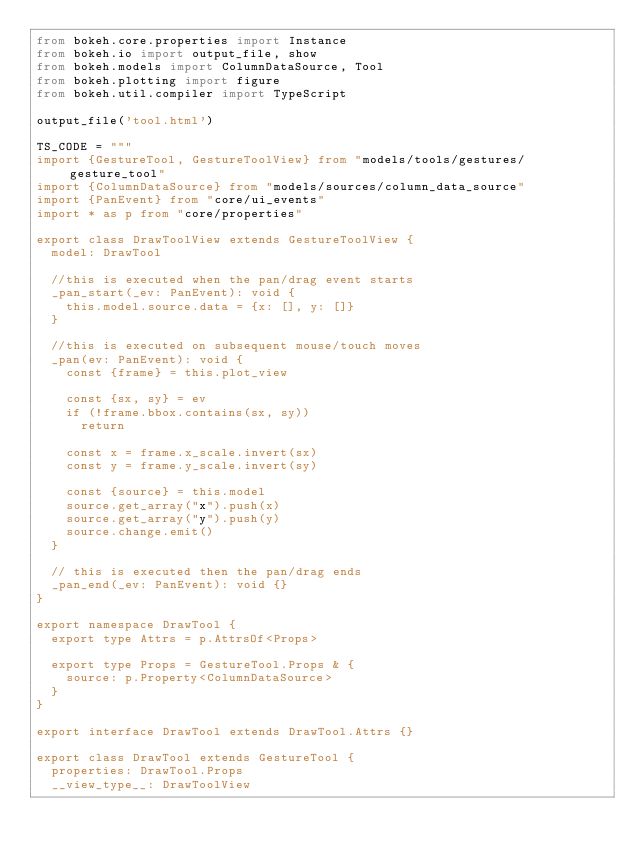<code> <loc_0><loc_0><loc_500><loc_500><_Python_>from bokeh.core.properties import Instance
from bokeh.io import output_file, show
from bokeh.models import ColumnDataSource, Tool
from bokeh.plotting import figure
from bokeh.util.compiler import TypeScript

output_file('tool.html')

TS_CODE = """
import {GestureTool, GestureToolView} from "models/tools/gestures/gesture_tool"
import {ColumnDataSource} from "models/sources/column_data_source"
import {PanEvent} from "core/ui_events"
import * as p from "core/properties"

export class DrawToolView extends GestureToolView {
  model: DrawTool

  //this is executed when the pan/drag event starts
  _pan_start(_ev: PanEvent): void {
    this.model.source.data = {x: [], y: []}
  }

  //this is executed on subsequent mouse/touch moves
  _pan(ev: PanEvent): void {
    const {frame} = this.plot_view

    const {sx, sy} = ev
    if (!frame.bbox.contains(sx, sy))
      return

    const x = frame.x_scale.invert(sx)
    const y = frame.y_scale.invert(sy)

    const {source} = this.model
    source.get_array("x").push(x)
    source.get_array("y").push(y)
    source.change.emit()
  }

  // this is executed then the pan/drag ends
  _pan_end(_ev: PanEvent): void {}
}

export namespace DrawTool {
  export type Attrs = p.AttrsOf<Props>

  export type Props = GestureTool.Props & {
    source: p.Property<ColumnDataSource>
  }
}

export interface DrawTool extends DrawTool.Attrs {}

export class DrawTool extends GestureTool {
  properties: DrawTool.Props
  __view_type__: DrawToolView
</code> 